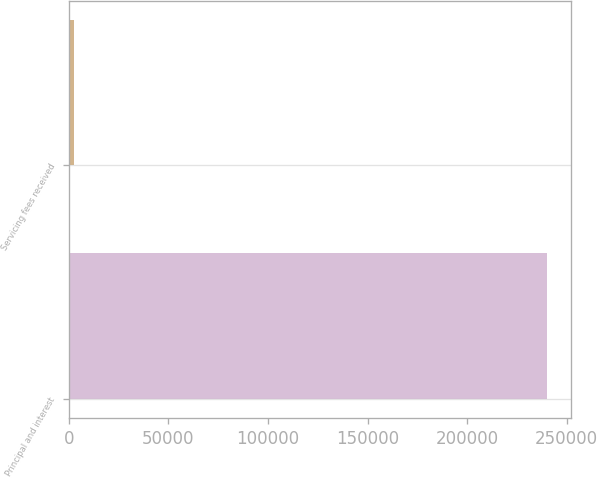Convert chart to OTSL. <chart><loc_0><loc_0><loc_500><loc_500><bar_chart><fcel>Principal and interest<fcel>Servicing fees received<nl><fcel>240211<fcel>2735<nl></chart> 